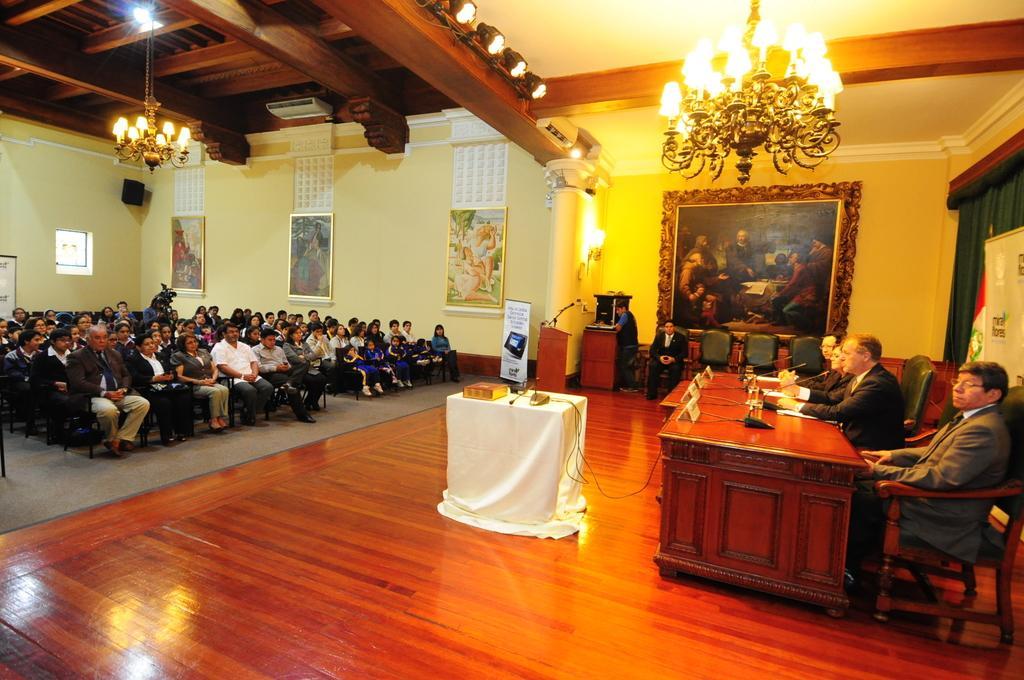Please provide a concise description of this image. In this picture there are group of people, those who are sitting at the left side of the image and there is a table on the stage at the right side of the image, there is a portrait at the right side of the image, it seems to be a conference meet. 